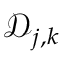Convert formula to latex. <formula><loc_0><loc_0><loc_500><loc_500>\mathcal { D } _ { j , k }</formula> 